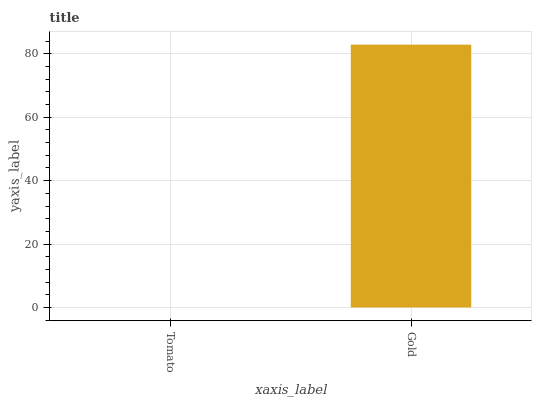Is Tomato the minimum?
Answer yes or no. Yes. Is Gold the maximum?
Answer yes or no. Yes. Is Gold the minimum?
Answer yes or no. No. Is Gold greater than Tomato?
Answer yes or no. Yes. Is Tomato less than Gold?
Answer yes or no. Yes. Is Tomato greater than Gold?
Answer yes or no. No. Is Gold less than Tomato?
Answer yes or no. No. Is Gold the high median?
Answer yes or no. Yes. Is Tomato the low median?
Answer yes or no. Yes. Is Tomato the high median?
Answer yes or no. No. Is Gold the low median?
Answer yes or no. No. 